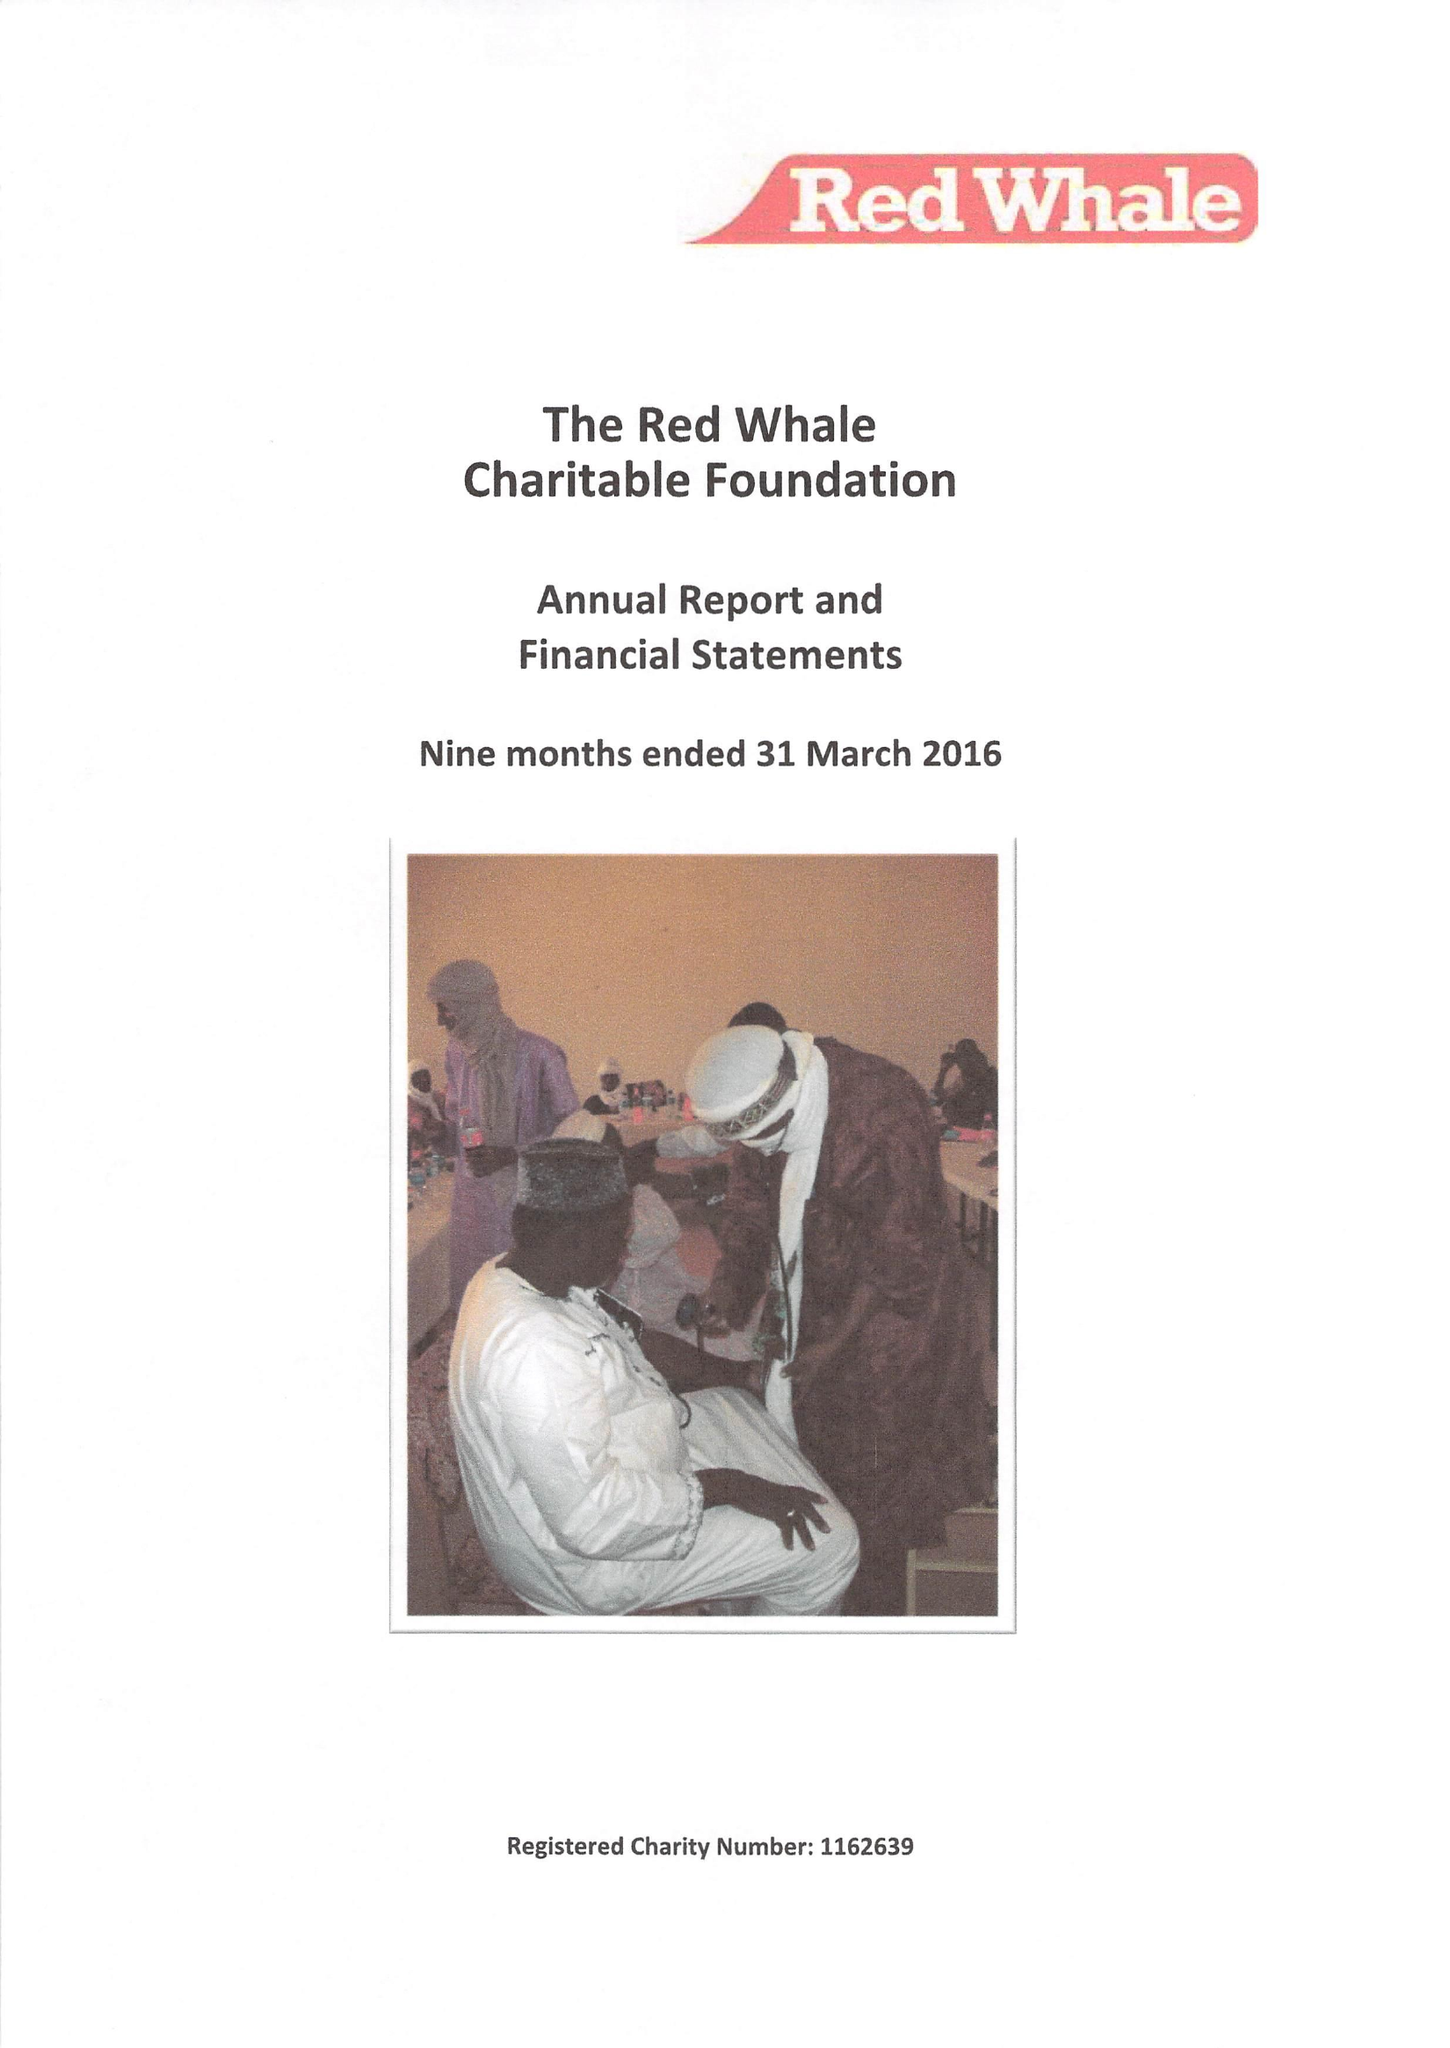What is the value for the charity_number?
Answer the question using a single word or phrase. 1162639 